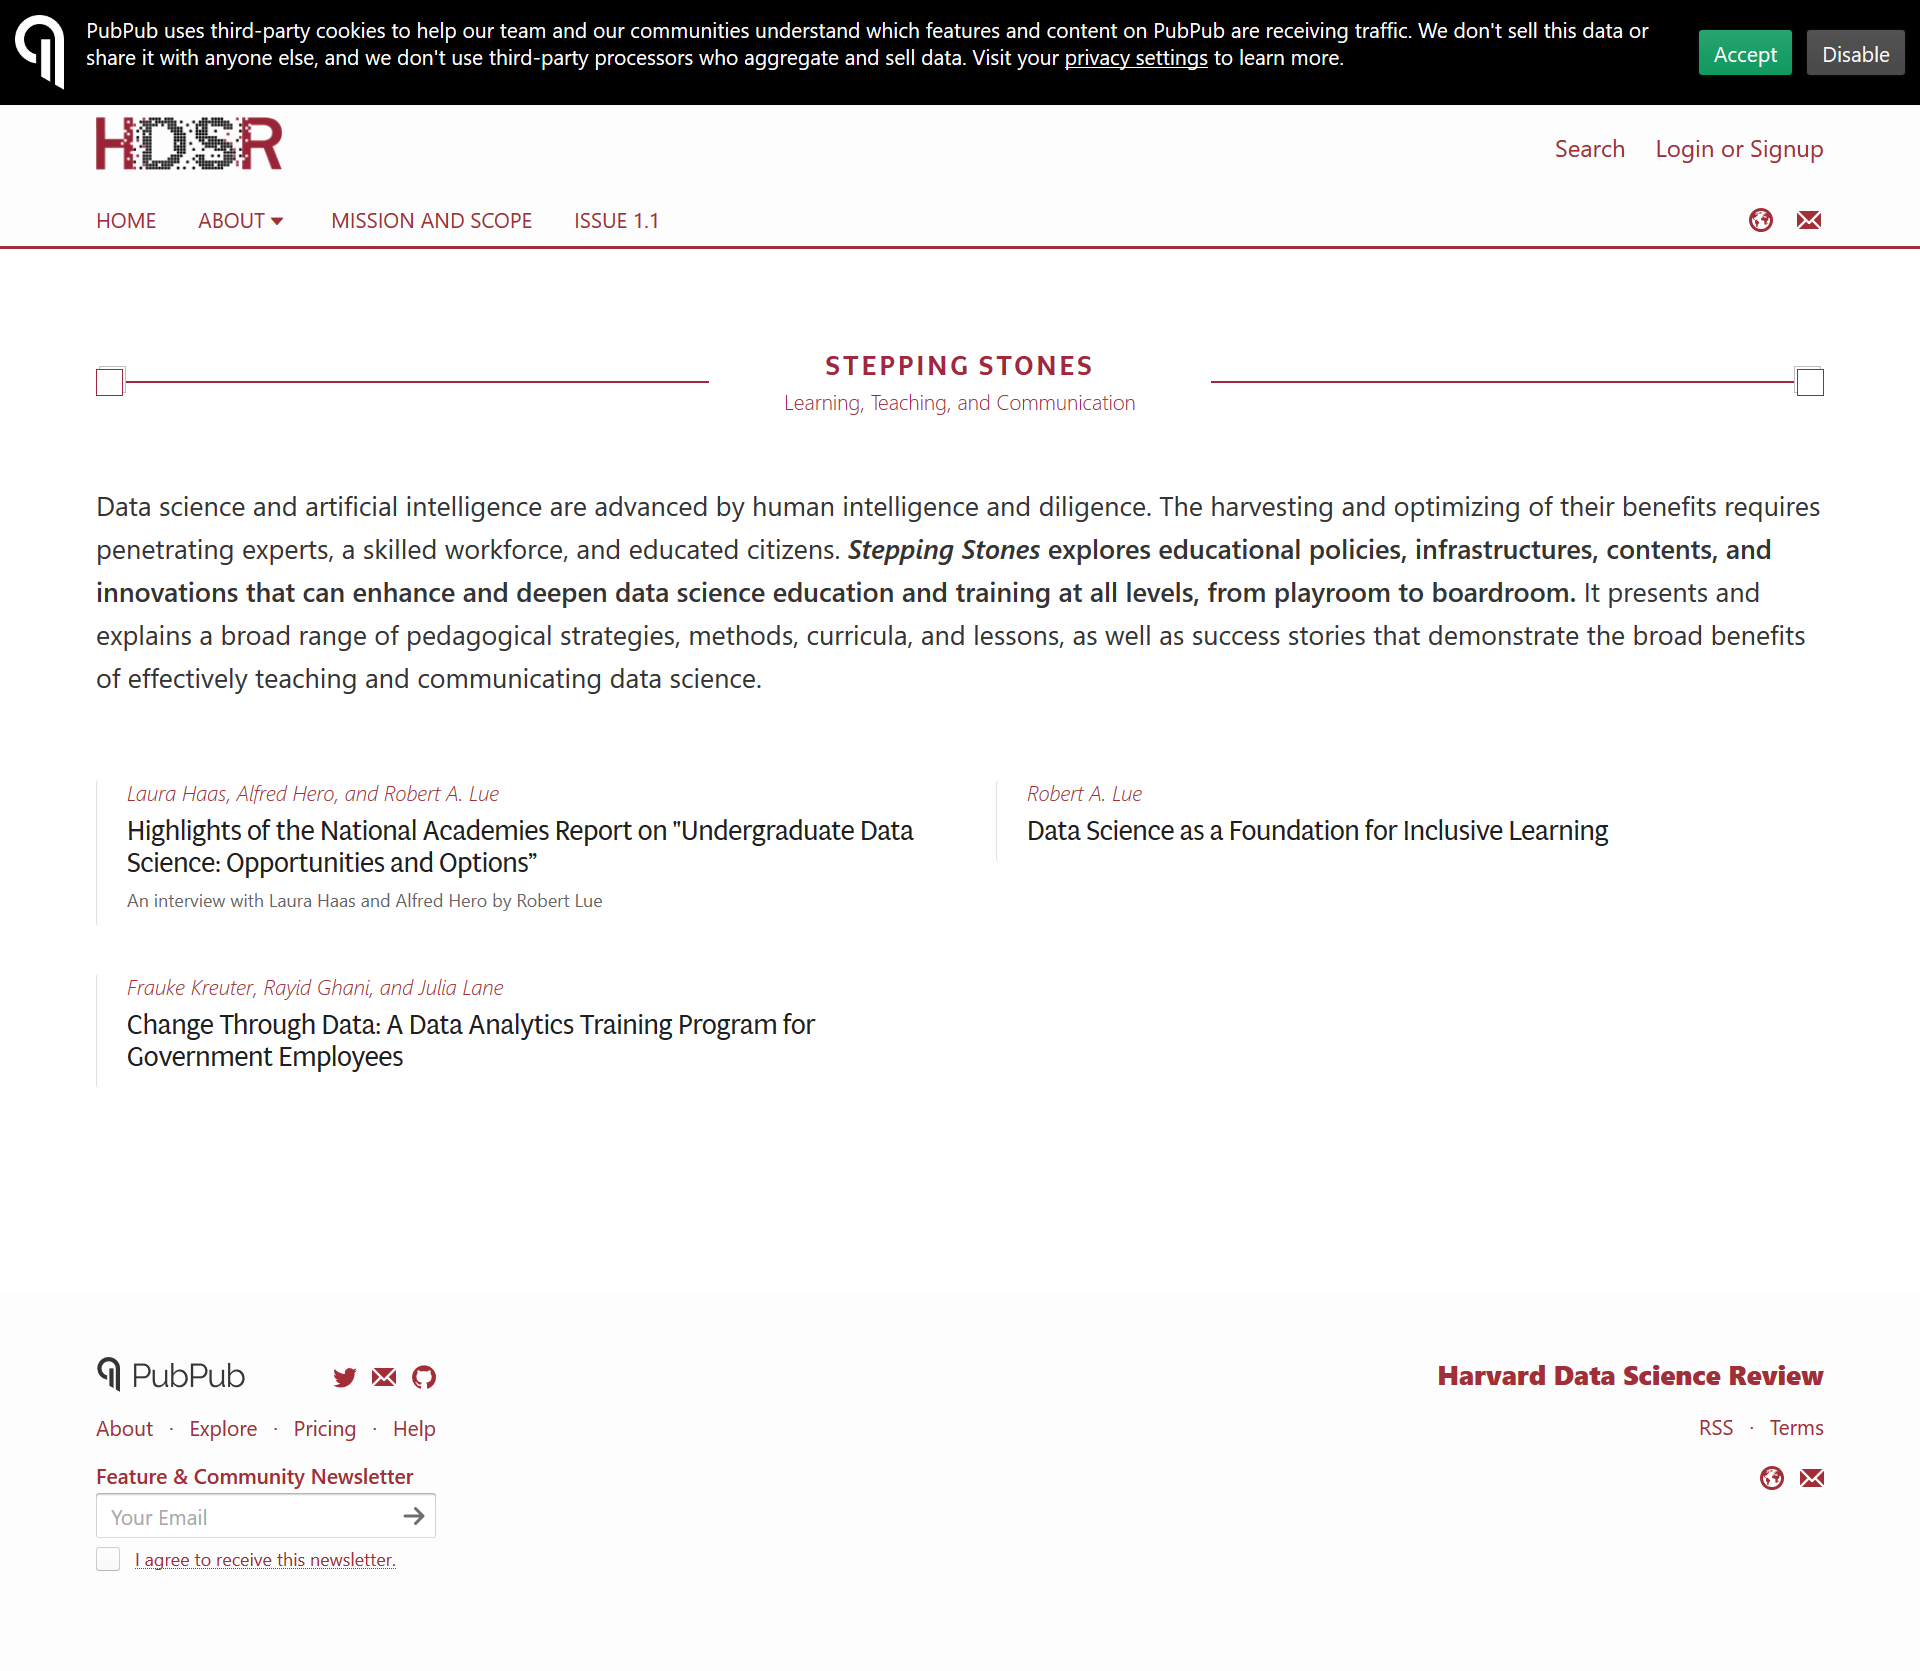Outline some significant characteristics in this image. To optimize data science and artificial intelligence, it is essential to have a skilled workforce, educated citizens, and experts with the ability to penetrate these fields. Data science and artificial intelligence are advanced through the intelligence and diligence of humans. Stepping Stones is an organization that examines educational policies, systems, content, and innovations to improve and expand data science education and training at various levels. 